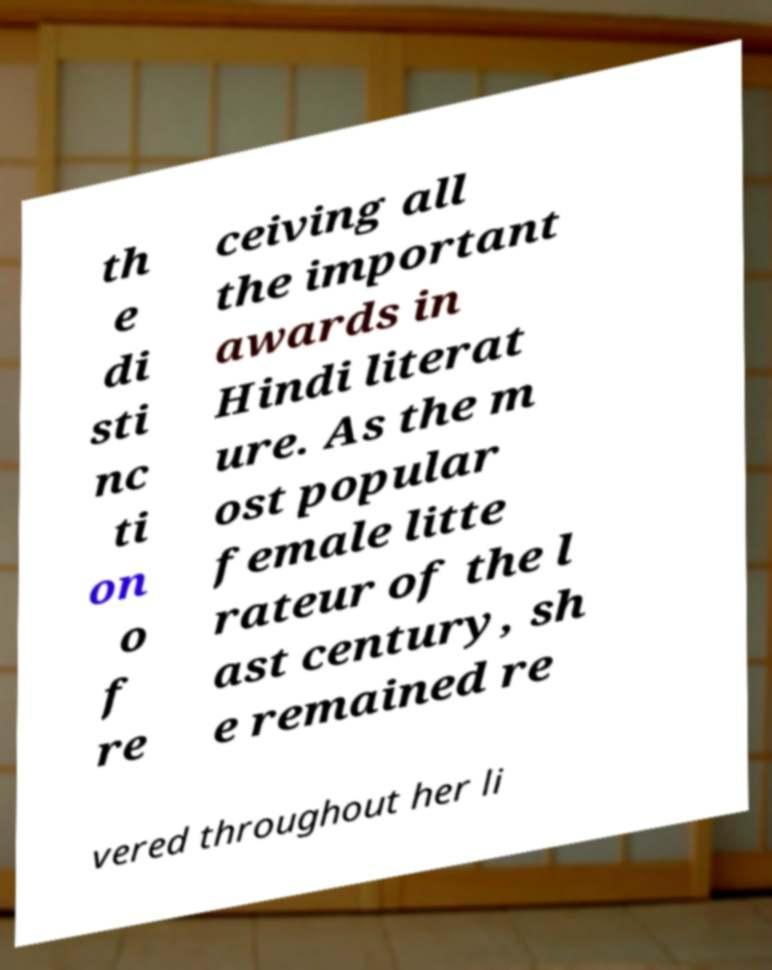Please read and relay the text visible in this image. What does it say? th e di sti nc ti on o f re ceiving all the important awards in Hindi literat ure. As the m ost popular female litte rateur of the l ast century, sh e remained re vered throughout her li 